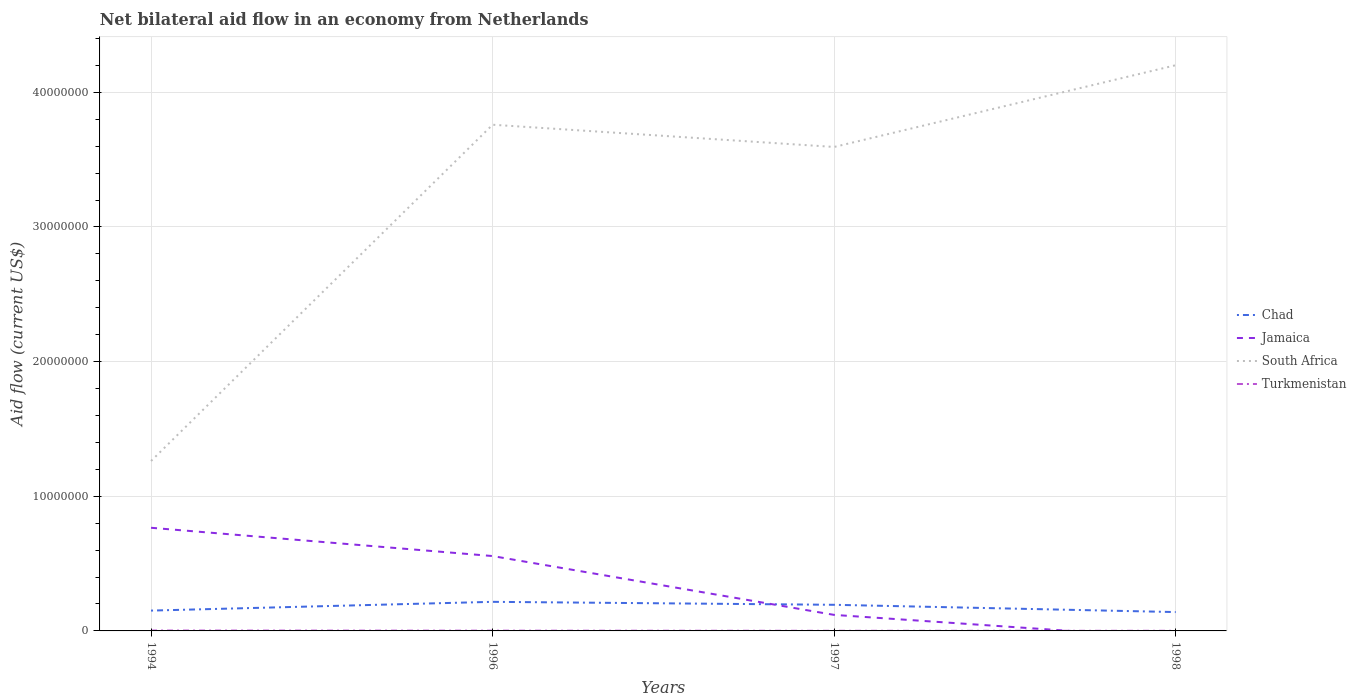How many different coloured lines are there?
Your response must be concise. 4. Does the line corresponding to Chad intersect with the line corresponding to South Africa?
Your answer should be compact. No. Across all years, what is the maximum net bilateral aid flow in Chad?
Provide a short and direct response. 1.40e+06. What is the total net bilateral aid flow in Chad in the graph?
Provide a short and direct response. -4.30e+05. What is the difference between the highest and the second highest net bilateral aid flow in Jamaica?
Your response must be concise. 7.66e+06. Is the net bilateral aid flow in Turkmenistan strictly greater than the net bilateral aid flow in Jamaica over the years?
Provide a succinct answer. No. How many lines are there?
Keep it short and to the point. 4. What is the difference between two consecutive major ticks on the Y-axis?
Ensure brevity in your answer.  1.00e+07. Does the graph contain grids?
Give a very brief answer. Yes. Where does the legend appear in the graph?
Offer a terse response. Center right. What is the title of the graph?
Ensure brevity in your answer.  Net bilateral aid flow in an economy from Netherlands. What is the label or title of the X-axis?
Your answer should be very brief. Years. What is the label or title of the Y-axis?
Keep it short and to the point. Aid flow (current US$). What is the Aid flow (current US$) of Chad in 1994?
Ensure brevity in your answer.  1.51e+06. What is the Aid flow (current US$) in Jamaica in 1994?
Offer a terse response. 7.66e+06. What is the Aid flow (current US$) in South Africa in 1994?
Offer a very short reply. 1.26e+07. What is the Aid flow (current US$) in Chad in 1996?
Your answer should be very brief. 2.16e+06. What is the Aid flow (current US$) in Jamaica in 1996?
Make the answer very short. 5.56e+06. What is the Aid flow (current US$) of South Africa in 1996?
Your answer should be very brief. 3.76e+07. What is the Aid flow (current US$) in Turkmenistan in 1996?
Offer a terse response. 2.00e+04. What is the Aid flow (current US$) of Chad in 1997?
Provide a short and direct response. 1.94e+06. What is the Aid flow (current US$) in Jamaica in 1997?
Provide a succinct answer. 1.19e+06. What is the Aid flow (current US$) of South Africa in 1997?
Offer a terse response. 3.59e+07. What is the Aid flow (current US$) in Turkmenistan in 1997?
Make the answer very short. 10000. What is the Aid flow (current US$) of Chad in 1998?
Offer a terse response. 1.40e+06. What is the Aid flow (current US$) in Jamaica in 1998?
Give a very brief answer. 0. What is the Aid flow (current US$) in South Africa in 1998?
Offer a terse response. 4.20e+07. Across all years, what is the maximum Aid flow (current US$) in Chad?
Make the answer very short. 2.16e+06. Across all years, what is the maximum Aid flow (current US$) in Jamaica?
Give a very brief answer. 7.66e+06. Across all years, what is the maximum Aid flow (current US$) in South Africa?
Your answer should be compact. 4.20e+07. Across all years, what is the maximum Aid flow (current US$) in Turkmenistan?
Offer a terse response. 3.00e+04. Across all years, what is the minimum Aid flow (current US$) of Chad?
Offer a terse response. 1.40e+06. Across all years, what is the minimum Aid flow (current US$) in Jamaica?
Ensure brevity in your answer.  0. Across all years, what is the minimum Aid flow (current US$) of South Africa?
Provide a succinct answer. 1.26e+07. What is the total Aid flow (current US$) in Chad in the graph?
Your answer should be very brief. 7.01e+06. What is the total Aid flow (current US$) of Jamaica in the graph?
Offer a very short reply. 1.44e+07. What is the total Aid flow (current US$) of South Africa in the graph?
Offer a terse response. 1.28e+08. What is the difference between the Aid flow (current US$) of Chad in 1994 and that in 1996?
Your answer should be very brief. -6.50e+05. What is the difference between the Aid flow (current US$) in Jamaica in 1994 and that in 1996?
Ensure brevity in your answer.  2.10e+06. What is the difference between the Aid flow (current US$) in South Africa in 1994 and that in 1996?
Keep it short and to the point. -2.50e+07. What is the difference between the Aid flow (current US$) in Chad in 1994 and that in 1997?
Provide a short and direct response. -4.30e+05. What is the difference between the Aid flow (current US$) of Jamaica in 1994 and that in 1997?
Provide a short and direct response. 6.47e+06. What is the difference between the Aid flow (current US$) of South Africa in 1994 and that in 1997?
Make the answer very short. -2.33e+07. What is the difference between the Aid flow (current US$) in Turkmenistan in 1994 and that in 1997?
Ensure brevity in your answer.  2.00e+04. What is the difference between the Aid flow (current US$) in Chad in 1994 and that in 1998?
Make the answer very short. 1.10e+05. What is the difference between the Aid flow (current US$) in South Africa in 1994 and that in 1998?
Give a very brief answer. -2.94e+07. What is the difference between the Aid flow (current US$) in Turkmenistan in 1994 and that in 1998?
Your answer should be compact. 2.00e+04. What is the difference between the Aid flow (current US$) of Jamaica in 1996 and that in 1997?
Offer a terse response. 4.37e+06. What is the difference between the Aid flow (current US$) in South Africa in 1996 and that in 1997?
Your answer should be very brief. 1.65e+06. What is the difference between the Aid flow (current US$) in Chad in 1996 and that in 1998?
Offer a terse response. 7.60e+05. What is the difference between the Aid flow (current US$) in South Africa in 1996 and that in 1998?
Provide a succinct answer. -4.42e+06. What is the difference between the Aid flow (current US$) of Chad in 1997 and that in 1998?
Your response must be concise. 5.40e+05. What is the difference between the Aid flow (current US$) of South Africa in 1997 and that in 1998?
Ensure brevity in your answer.  -6.07e+06. What is the difference between the Aid flow (current US$) of Turkmenistan in 1997 and that in 1998?
Provide a short and direct response. 0. What is the difference between the Aid flow (current US$) of Chad in 1994 and the Aid flow (current US$) of Jamaica in 1996?
Your answer should be very brief. -4.05e+06. What is the difference between the Aid flow (current US$) in Chad in 1994 and the Aid flow (current US$) in South Africa in 1996?
Your answer should be very brief. -3.61e+07. What is the difference between the Aid flow (current US$) in Chad in 1994 and the Aid flow (current US$) in Turkmenistan in 1996?
Ensure brevity in your answer.  1.49e+06. What is the difference between the Aid flow (current US$) in Jamaica in 1994 and the Aid flow (current US$) in South Africa in 1996?
Make the answer very short. -2.99e+07. What is the difference between the Aid flow (current US$) of Jamaica in 1994 and the Aid flow (current US$) of Turkmenistan in 1996?
Your answer should be very brief. 7.64e+06. What is the difference between the Aid flow (current US$) in South Africa in 1994 and the Aid flow (current US$) in Turkmenistan in 1996?
Give a very brief answer. 1.26e+07. What is the difference between the Aid flow (current US$) of Chad in 1994 and the Aid flow (current US$) of Jamaica in 1997?
Keep it short and to the point. 3.20e+05. What is the difference between the Aid flow (current US$) of Chad in 1994 and the Aid flow (current US$) of South Africa in 1997?
Offer a very short reply. -3.44e+07. What is the difference between the Aid flow (current US$) of Chad in 1994 and the Aid flow (current US$) of Turkmenistan in 1997?
Make the answer very short. 1.50e+06. What is the difference between the Aid flow (current US$) in Jamaica in 1994 and the Aid flow (current US$) in South Africa in 1997?
Offer a terse response. -2.83e+07. What is the difference between the Aid flow (current US$) of Jamaica in 1994 and the Aid flow (current US$) of Turkmenistan in 1997?
Your answer should be compact. 7.65e+06. What is the difference between the Aid flow (current US$) in South Africa in 1994 and the Aid flow (current US$) in Turkmenistan in 1997?
Your answer should be very brief. 1.26e+07. What is the difference between the Aid flow (current US$) in Chad in 1994 and the Aid flow (current US$) in South Africa in 1998?
Give a very brief answer. -4.05e+07. What is the difference between the Aid flow (current US$) in Chad in 1994 and the Aid flow (current US$) in Turkmenistan in 1998?
Keep it short and to the point. 1.50e+06. What is the difference between the Aid flow (current US$) in Jamaica in 1994 and the Aid flow (current US$) in South Africa in 1998?
Your answer should be very brief. -3.44e+07. What is the difference between the Aid flow (current US$) in Jamaica in 1994 and the Aid flow (current US$) in Turkmenistan in 1998?
Give a very brief answer. 7.65e+06. What is the difference between the Aid flow (current US$) of South Africa in 1994 and the Aid flow (current US$) of Turkmenistan in 1998?
Provide a succinct answer. 1.26e+07. What is the difference between the Aid flow (current US$) of Chad in 1996 and the Aid flow (current US$) of Jamaica in 1997?
Offer a very short reply. 9.70e+05. What is the difference between the Aid flow (current US$) of Chad in 1996 and the Aid flow (current US$) of South Africa in 1997?
Ensure brevity in your answer.  -3.38e+07. What is the difference between the Aid flow (current US$) of Chad in 1996 and the Aid flow (current US$) of Turkmenistan in 1997?
Keep it short and to the point. 2.15e+06. What is the difference between the Aid flow (current US$) of Jamaica in 1996 and the Aid flow (current US$) of South Africa in 1997?
Your answer should be compact. -3.04e+07. What is the difference between the Aid flow (current US$) of Jamaica in 1996 and the Aid flow (current US$) of Turkmenistan in 1997?
Your answer should be very brief. 5.55e+06. What is the difference between the Aid flow (current US$) in South Africa in 1996 and the Aid flow (current US$) in Turkmenistan in 1997?
Provide a short and direct response. 3.76e+07. What is the difference between the Aid flow (current US$) of Chad in 1996 and the Aid flow (current US$) of South Africa in 1998?
Provide a short and direct response. -3.98e+07. What is the difference between the Aid flow (current US$) of Chad in 1996 and the Aid flow (current US$) of Turkmenistan in 1998?
Your answer should be compact. 2.15e+06. What is the difference between the Aid flow (current US$) in Jamaica in 1996 and the Aid flow (current US$) in South Africa in 1998?
Offer a terse response. -3.64e+07. What is the difference between the Aid flow (current US$) in Jamaica in 1996 and the Aid flow (current US$) in Turkmenistan in 1998?
Your response must be concise. 5.55e+06. What is the difference between the Aid flow (current US$) in South Africa in 1996 and the Aid flow (current US$) in Turkmenistan in 1998?
Make the answer very short. 3.76e+07. What is the difference between the Aid flow (current US$) in Chad in 1997 and the Aid flow (current US$) in South Africa in 1998?
Give a very brief answer. -4.01e+07. What is the difference between the Aid flow (current US$) in Chad in 1997 and the Aid flow (current US$) in Turkmenistan in 1998?
Your response must be concise. 1.93e+06. What is the difference between the Aid flow (current US$) in Jamaica in 1997 and the Aid flow (current US$) in South Africa in 1998?
Ensure brevity in your answer.  -4.08e+07. What is the difference between the Aid flow (current US$) of Jamaica in 1997 and the Aid flow (current US$) of Turkmenistan in 1998?
Offer a terse response. 1.18e+06. What is the difference between the Aid flow (current US$) of South Africa in 1997 and the Aid flow (current US$) of Turkmenistan in 1998?
Provide a succinct answer. 3.59e+07. What is the average Aid flow (current US$) of Chad per year?
Keep it short and to the point. 1.75e+06. What is the average Aid flow (current US$) in Jamaica per year?
Make the answer very short. 3.60e+06. What is the average Aid flow (current US$) of South Africa per year?
Provide a succinct answer. 3.20e+07. What is the average Aid flow (current US$) in Turkmenistan per year?
Your answer should be compact. 1.75e+04. In the year 1994, what is the difference between the Aid flow (current US$) in Chad and Aid flow (current US$) in Jamaica?
Make the answer very short. -6.15e+06. In the year 1994, what is the difference between the Aid flow (current US$) in Chad and Aid flow (current US$) in South Africa?
Ensure brevity in your answer.  -1.11e+07. In the year 1994, what is the difference between the Aid flow (current US$) of Chad and Aid flow (current US$) of Turkmenistan?
Offer a very short reply. 1.48e+06. In the year 1994, what is the difference between the Aid flow (current US$) in Jamaica and Aid flow (current US$) in South Africa?
Keep it short and to the point. -4.96e+06. In the year 1994, what is the difference between the Aid flow (current US$) in Jamaica and Aid flow (current US$) in Turkmenistan?
Your answer should be very brief. 7.63e+06. In the year 1994, what is the difference between the Aid flow (current US$) in South Africa and Aid flow (current US$) in Turkmenistan?
Provide a succinct answer. 1.26e+07. In the year 1996, what is the difference between the Aid flow (current US$) in Chad and Aid flow (current US$) in Jamaica?
Offer a terse response. -3.40e+06. In the year 1996, what is the difference between the Aid flow (current US$) in Chad and Aid flow (current US$) in South Africa?
Give a very brief answer. -3.54e+07. In the year 1996, what is the difference between the Aid flow (current US$) in Chad and Aid flow (current US$) in Turkmenistan?
Your answer should be very brief. 2.14e+06. In the year 1996, what is the difference between the Aid flow (current US$) in Jamaica and Aid flow (current US$) in South Africa?
Offer a very short reply. -3.20e+07. In the year 1996, what is the difference between the Aid flow (current US$) in Jamaica and Aid flow (current US$) in Turkmenistan?
Give a very brief answer. 5.54e+06. In the year 1996, what is the difference between the Aid flow (current US$) in South Africa and Aid flow (current US$) in Turkmenistan?
Keep it short and to the point. 3.76e+07. In the year 1997, what is the difference between the Aid flow (current US$) of Chad and Aid flow (current US$) of Jamaica?
Provide a short and direct response. 7.50e+05. In the year 1997, what is the difference between the Aid flow (current US$) of Chad and Aid flow (current US$) of South Africa?
Keep it short and to the point. -3.40e+07. In the year 1997, what is the difference between the Aid flow (current US$) in Chad and Aid flow (current US$) in Turkmenistan?
Your response must be concise. 1.93e+06. In the year 1997, what is the difference between the Aid flow (current US$) in Jamaica and Aid flow (current US$) in South Africa?
Offer a terse response. -3.48e+07. In the year 1997, what is the difference between the Aid flow (current US$) of Jamaica and Aid flow (current US$) of Turkmenistan?
Provide a short and direct response. 1.18e+06. In the year 1997, what is the difference between the Aid flow (current US$) in South Africa and Aid flow (current US$) in Turkmenistan?
Give a very brief answer. 3.59e+07. In the year 1998, what is the difference between the Aid flow (current US$) in Chad and Aid flow (current US$) in South Africa?
Your response must be concise. -4.06e+07. In the year 1998, what is the difference between the Aid flow (current US$) in Chad and Aid flow (current US$) in Turkmenistan?
Offer a terse response. 1.39e+06. In the year 1998, what is the difference between the Aid flow (current US$) in South Africa and Aid flow (current US$) in Turkmenistan?
Your answer should be very brief. 4.20e+07. What is the ratio of the Aid flow (current US$) of Chad in 1994 to that in 1996?
Offer a very short reply. 0.7. What is the ratio of the Aid flow (current US$) in Jamaica in 1994 to that in 1996?
Your response must be concise. 1.38. What is the ratio of the Aid flow (current US$) in South Africa in 1994 to that in 1996?
Your answer should be compact. 0.34. What is the ratio of the Aid flow (current US$) in Turkmenistan in 1994 to that in 1996?
Offer a terse response. 1.5. What is the ratio of the Aid flow (current US$) in Chad in 1994 to that in 1997?
Offer a terse response. 0.78. What is the ratio of the Aid flow (current US$) in Jamaica in 1994 to that in 1997?
Give a very brief answer. 6.44. What is the ratio of the Aid flow (current US$) of South Africa in 1994 to that in 1997?
Offer a terse response. 0.35. What is the ratio of the Aid flow (current US$) in Chad in 1994 to that in 1998?
Provide a succinct answer. 1.08. What is the ratio of the Aid flow (current US$) in South Africa in 1994 to that in 1998?
Keep it short and to the point. 0.3. What is the ratio of the Aid flow (current US$) of Chad in 1996 to that in 1997?
Make the answer very short. 1.11. What is the ratio of the Aid flow (current US$) in Jamaica in 1996 to that in 1997?
Offer a terse response. 4.67. What is the ratio of the Aid flow (current US$) of South Africa in 1996 to that in 1997?
Keep it short and to the point. 1.05. What is the ratio of the Aid flow (current US$) of Turkmenistan in 1996 to that in 1997?
Provide a succinct answer. 2. What is the ratio of the Aid flow (current US$) in Chad in 1996 to that in 1998?
Provide a short and direct response. 1.54. What is the ratio of the Aid flow (current US$) of South Africa in 1996 to that in 1998?
Give a very brief answer. 0.89. What is the ratio of the Aid flow (current US$) in Turkmenistan in 1996 to that in 1998?
Offer a terse response. 2. What is the ratio of the Aid flow (current US$) of Chad in 1997 to that in 1998?
Provide a short and direct response. 1.39. What is the ratio of the Aid flow (current US$) in South Africa in 1997 to that in 1998?
Provide a short and direct response. 0.86. What is the ratio of the Aid flow (current US$) in Turkmenistan in 1997 to that in 1998?
Your answer should be compact. 1. What is the difference between the highest and the second highest Aid flow (current US$) of Chad?
Provide a short and direct response. 2.20e+05. What is the difference between the highest and the second highest Aid flow (current US$) of Jamaica?
Your answer should be compact. 2.10e+06. What is the difference between the highest and the second highest Aid flow (current US$) of South Africa?
Offer a terse response. 4.42e+06. What is the difference between the highest and the lowest Aid flow (current US$) in Chad?
Keep it short and to the point. 7.60e+05. What is the difference between the highest and the lowest Aid flow (current US$) in Jamaica?
Your answer should be very brief. 7.66e+06. What is the difference between the highest and the lowest Aid flow (current US$) of South Africa?
Your answer should be compact. 2.94e+07. What is the difference between the highest and the lowest Aid flow (current US$) of Turkmenistan?
Your answer should be compact. 2.00e+04. 